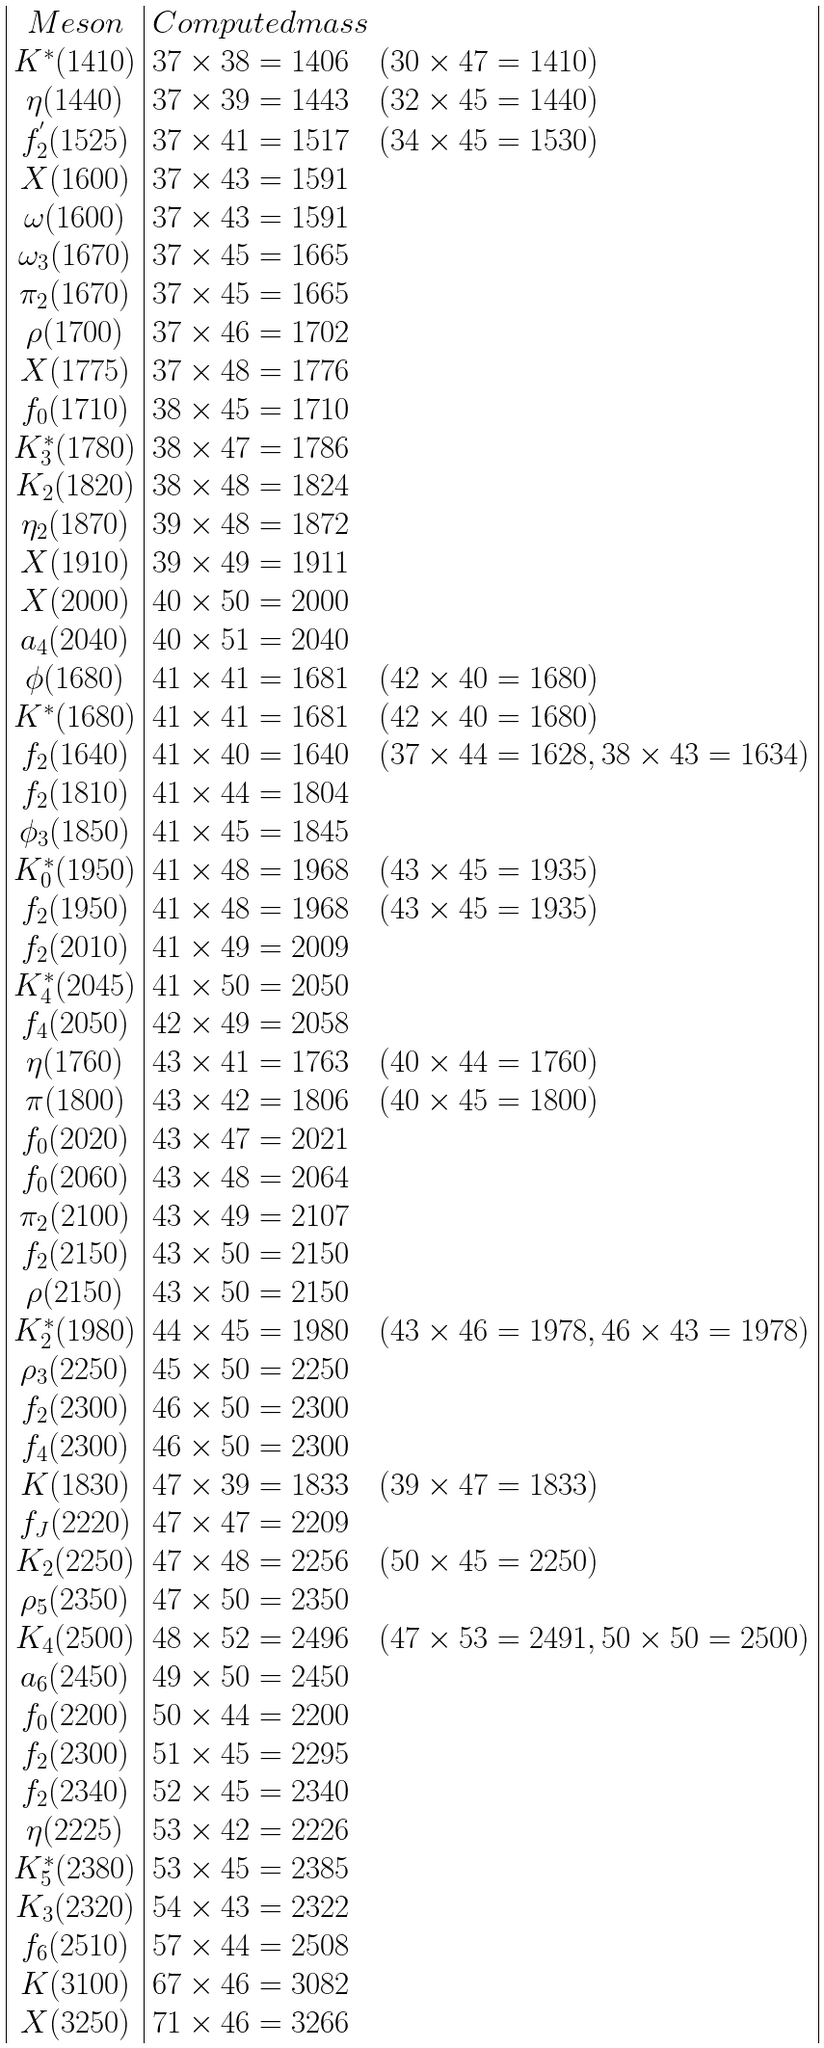<formula> <loc_0><loc_0><loc_500><loc_500>\begin{array} { | c | l | } M e s o n & C o m p u t e d m a s s \\ K ^ { * } ( 1 4 1 0 ) & { 3 7 } \times 3 8 = 1 4 0 6 \quad ( 3 0 \times 4 7 = 1 4 1 0 ) \\ \eta ( 1 4 4 0 ) & { 3 7 } \times 3 9 = 1 4 4 3 \quad ( 3 2 \times 4 5 = 1 4 4 0 ) \\ f _ { 2 } ^ { ^ { \prime } } ( 1 5 2 5 ) & { 3 7 } \times 4 1 = 1 5 1 7 \quad ( 3 4 \times 4 5 = 1 5 3 0 ) \\ X ( 1 6 0 0 ) & { 3 7 } \times 4 3 = 1 5 9 1 \\ \omega ( 1 6 0 0 ) & { 3 7 } \times 4 3 = 1 5 9 1 \\ \omega _ { 3 } ( 1 6 7 0 ) & { 3 7 } \times 4 5 = 1 6 6 5 \\ \pi _ { 2 } ( 1 6 7 0 ) & { 3 7 } \times 4 5 = 1 6 6 5 \\ \rho ( 1 7 0 0 ) & { 3 7 } \times 4 6 = 1 7 0 2 \\ X ( 1 7 7 5 ) & { 3 7 } \times 4 8 = 1 7 7 6 \\ f _ { 0 } ( 1 7 1 0 ) & 3 8 \times 4 5 = 1 7 1 0 \\ K _ { 3 } ^ { * } ( 1 7 8 0 ) & 3 8 \times 4 7 = 1 7 8 6 \\ K _ { 2 } ( 1 8 2 0 ) & 3 8 \times 4 8 = 1 8 2 4 \\ \eta _ { 2 } ( 1 8 7 0 ) & 3 9 \times 4 8 = 1 8 7 2 \\ X ( 1 9 1 0 ) & 3 9 \times 4 9 = 1 9 1 1 \\ X ( 2 0 0 0 ) & 4 0 \times 5 0 = 2 0 0 0 \\ a _ { 4 } ( 2 0 4 0 ) & 4 0 \times 5 1 = 2 0 4 0 \\ \phi ( 1 6 8 0 ) & { 4 1 } \times 4 1 = 1 6 8 1 \quad ( 4 2 \times 4 0 = 1 6 8 0 ) \\ K ^ { * } ( 1 6 8 0 ) & { 4 1 } \times 4 1 = 1 6 8 1 \quad ( 4 2 \times 4 0 = 1 6 8 0 ) \\ f _ { 2 } ( 1 6 4 0 ) & { 4 1 } \times 4 0 = 1 6 4 0 \quad ( { 3 7 } \times 4 4 = 1 6 2 8 , 3 8 \times 4 3 = 1 6 3 4 ) \\ f _ { 2 } ( 1 8 1 0 ) & { 4 1 } \times 4 4 = 1 8 0 4 \\ \phi _ { 3 } ( 1 8 5 0 ) & { 4 1 } \times 4 5 = 1 8 4 5 \\ K _ { 0 } ^ { * } ( 1 9 5 0 ) & { 4 1 } \times 4 8 = 1 9 6 8 \quad ( { 4 3 } \times 4 5 = 1 9 3 5 ) \\ f _ { 2 } ( 1 9 5 0 ) & { 4 1 } \times 4 8 = 1 9 6 8 \quad ( { 4 3 } \times 4 5 = 1 9 3 5 ) \\ f _ { 2 } ( 2 0 1 0 ) & { 4 1 } \times 4 9 = 2 0 0 9 \\ K _ { 4 } ^ { * } ( 2 0 4 5 ) & { 4 1 } \times 5 0 = 2 0 5 0 \\ f _ { 4 } ( 2 0 5 0 ) & 4 2 \times 4 9 = 2 0 5 8 \\ \eta ( 1 7 6 0 ) & { 4 3 } \times 4 1 = 1 7 6 3 \quad ( 4 0 \times 4 4 = 1 7 6 0 ) \\ \pi ( 1 8 0 0 ) & { 4 3 } \times 4 2 = 1 8 0 6 \quad ( 4 0 \times 4 5 = 1 8 0 0 ) \\ f _ { 0 } ( 2 0 2 0 ) & { 4 3 } \times 4 7 = 2 0 2 1 \\ f _ { 0 } ( 2 0 6 0 ) & { 4 3 } \times 4 8 = 2 0 6 4 \\ \pi _ { 2 } ( 2 1 0 0 ) & { 4 3 } \times 4 9 = 2 1 0 7 \\ f _ { 2 } ( 2 1 5 0 ) & { 4 3 } \times 5 0 = 2 1 5 0 \\ \rho ( 2 1 5 0 ) & { 4 3 } \times 5 0 = 2 1 5 0 \\ K _ { 2 } ^ { * } ( 1 9 8 0 ) & 4 4 \times 4 5 = 1 9 8 0 \quad ( { 4 3 } \times 4 6 = 1 9 7 8 , 4 6 \times 4 3 = 1 9 7 8 ) \\ \rho _ { 3 } ( 2 2 5 0 ) & 4 5 \times 5 0 = 2 2 5 0 \\ f _ { 2 } ( 2 3 0 0 ) & 4 6 \times 5 0 = 2 3 0 0 \\ f _ { 4 } ( 2 3 0 0 ) & 4 6 \times 5 0 = 2 3 0 0 \\ K ( 1 8 3 0 ) & { 4 7 } \times 3 9 = 1 8 3 3 \quad ( 3 9 \times 4 7 = 1 8 3 3 ) \\ f _ { J } ( 2 2 2 0 ) & { 4 7 } \times 4 7 = 2 2 0 9 \\ K _ { 2 } ( 2 2 5 0 ) & { 4 7 } \times 4 8 = 2 2 5 6 \quad ( 5 0 \times 4 5 = 2 2 5 0 ) \\ \rho _ { 5 } ( 2 3 5 0 ) & { 4 7 } \times 5 0 = 2 3 5 0 \\ K _ { 4 } ( 2 5 0 0 ) & 4 8 \times 5 2 = 2 4 9 6 \quad ( { 4 7 } \times 5 3 = 2 4 9 1 , 5 0 \times 5 0 = 2 5 0 0 ) \\ a _ { 6 } ( 2 4 5 0 ) & 4 9 \times 5 0 = 2 4 5 0 \\ f _ { 0 } ( 2 2 0 0 ) & 5 0 \times 4 4 = 2 2 0 0 \\ f _ { 2 } ( 2 3 0 0 ) & 5 1 \times 4 5 = 2 2 9 5 \\ f _ { 2 } ( 2 3 4 0 ) & 5 2 \times 4 5 = 2 3 4 0 \\ \eta ( 2 2 2 5 ) & { 5 3 } \times 4 2 = 2 2 2 6 \\ K _ { 5 } ^ { * } ( 2 3 8 0 ) & { 5 3 } \times 4 5 = 2 3 8 5 \\ K _ { 3 } ( 2 3 2 0 ) & 5 4 \times 4 3 = 2 3 2 2 \\ f _ { 6 } ( 2 5 1 0 ) & 5 7 \times 4 4 = 2 5 0 8 \\ K ( 3 1 0 0 ) & { 6 7 } \times 4 6 = 3 0 8 2 \\ X ( 3 2 5 0 ) & { 7 1 } \times 4 6 = 3 2 6 6 \\ \end{array}</formula> 